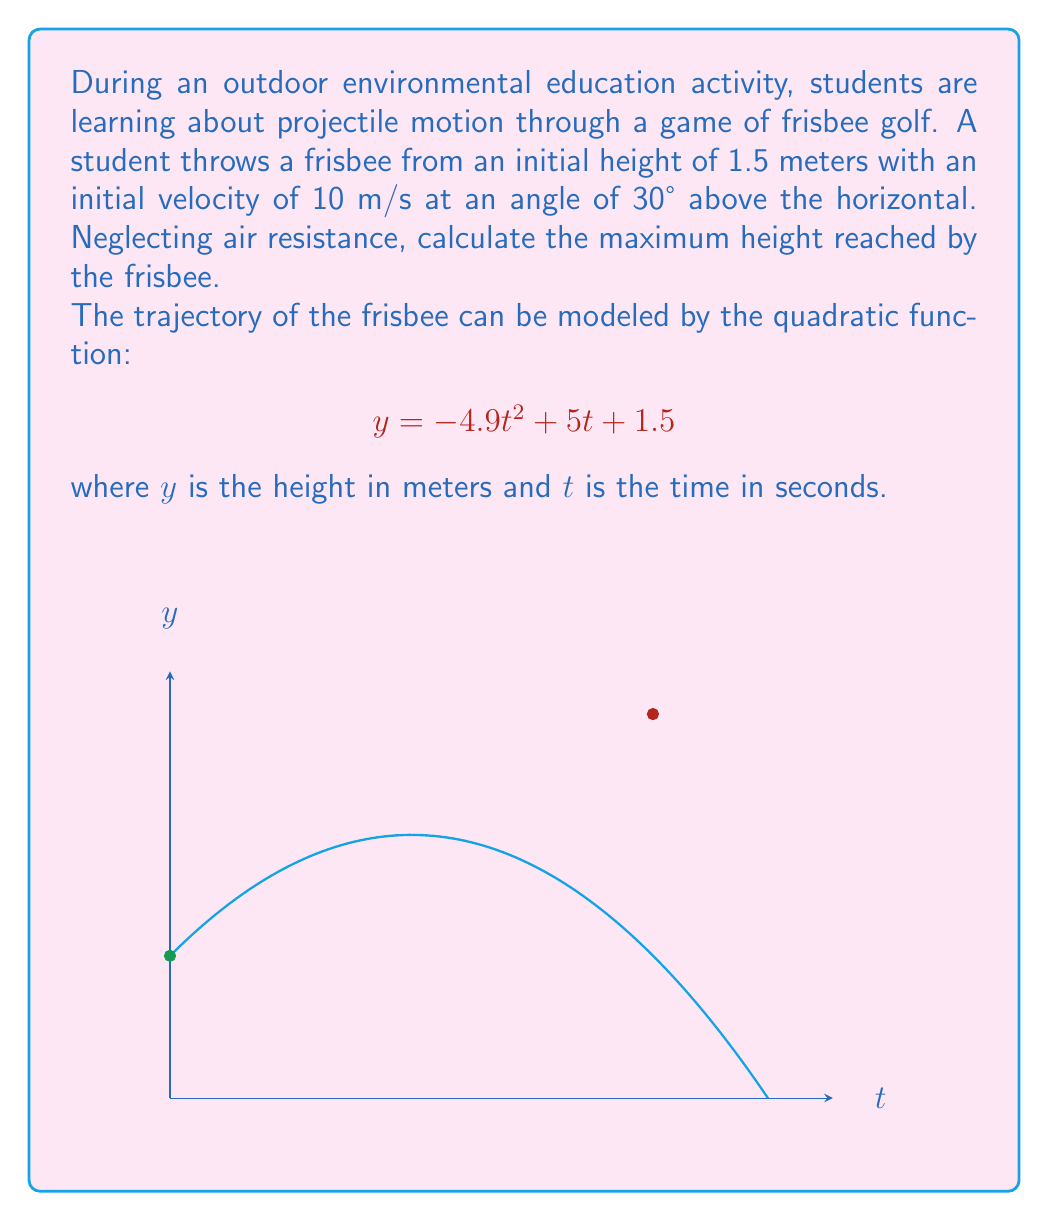Show me your answer to this math problem. To find the maximum height, we need to follow these steps:

1) The quadratic function is in the form $y = -at^2 + bt + c$, where:
   $a = 4.9$, $b = 5$, and $c = 1.5$

2) For a quadratic function, the maximum or minimum point occurs at $t = -\frac{b}{2a}$

3) Substituting our values:
   
   $$t = -\frac{5}{2(-4.9)} = \frac{5}{9.8} \approx 0.51 \text{ seconds}$$

4) To find the maximum height, we substitute this t-value back into our original equation:

   $$y = -4.9(0.51)^2 + 5(0.51) + 1.5$$
   
   $$y = -1.27 + 2.55 + 1.5 = 2.78$$

5) Therefore, the maximum height is approximately 2.78 meters.

6) To calculate the height gained, we subtract the initial height:

   $$2.78 - 1.5 = 1.28 \text{ meters}$$

Thus, the frisbee reaches a maximum height of 2.78 meters, gaining 1.28 meters from its initial height.
Answer: 2.78 meters 